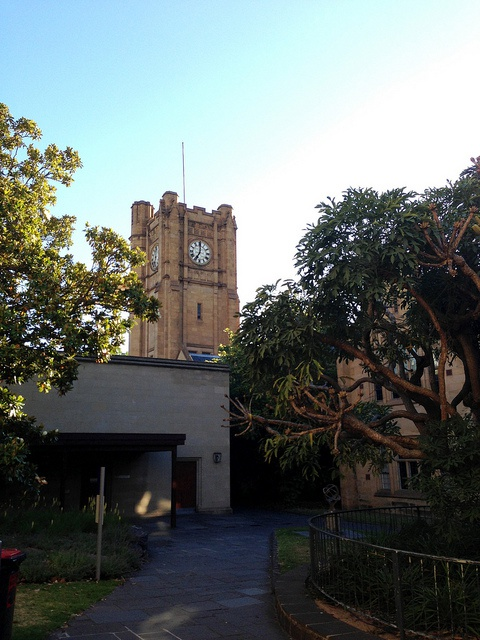Describe the objects in this image and their specific colors. I can see clock in lightblue, gray, darkgray, and black tones and clock in lightblue, gray, and darkgray tones in this image. 